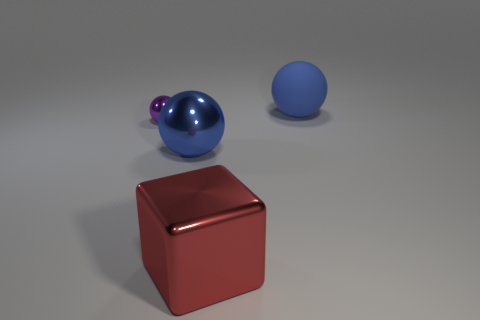Subtract all shiny balls. How many balls are left? 1 Subtract all purple cylinders. How many blue balls are left? 2 Add 3 purple balls. How many objects exist? 7 Subtract 2 spheres. How many spheres are left? 1 Subtract all blocks. How many objects are left? 3 Subtract all tiny cyan rubber things. Subtract all big blue rubber balls. How many objects are left? 3 Add 2 big spheres. How many big spheres are left? 4 Add 4 large blue matte things. How many large blue matte things exist? 5 Subtract 1 red blocks. How many objects are left? 3 Subtract all gray cubes. Subtract all red balls. How many cubes are left? 1 